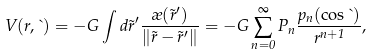<formula> <loc_0><loc_0><loc_500><loc_500>V ( r , \theta ) = - G \int d \vec { r } ^ { \prime } \frac { \rho ( \vec { r } ^ { \prime } ) } { \| \vec { r } - \vec { r } ^ { \prime } \| } = - G \sum _ { n = 0 } ^ { \infty } P _ { n } \frac { p _ { n } ( \cos \theta ) } { r ^ { n + 1 } } ,</formula> 